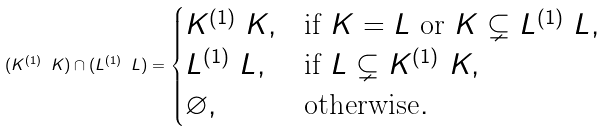<formula> <loc_0><loc_0><loc_500><loc_500>( K ^ { ( 1 ) } \ K ) \cap ( L ^ { ( 1 ) } \ L ) = \begin{cases} K ^ { ( 1 ) } \ K , & \text {if } K = L \text { or } K \subsetneq L ^ { ( 1 ) } \ L , \\ L ^ { ( 1 ) } \ L , & \text {if } L \subsetneq K ^ { ( 1 ) } \ K , \\ \varnothing , & \text {otherwise} . \end{cases}</formula> 